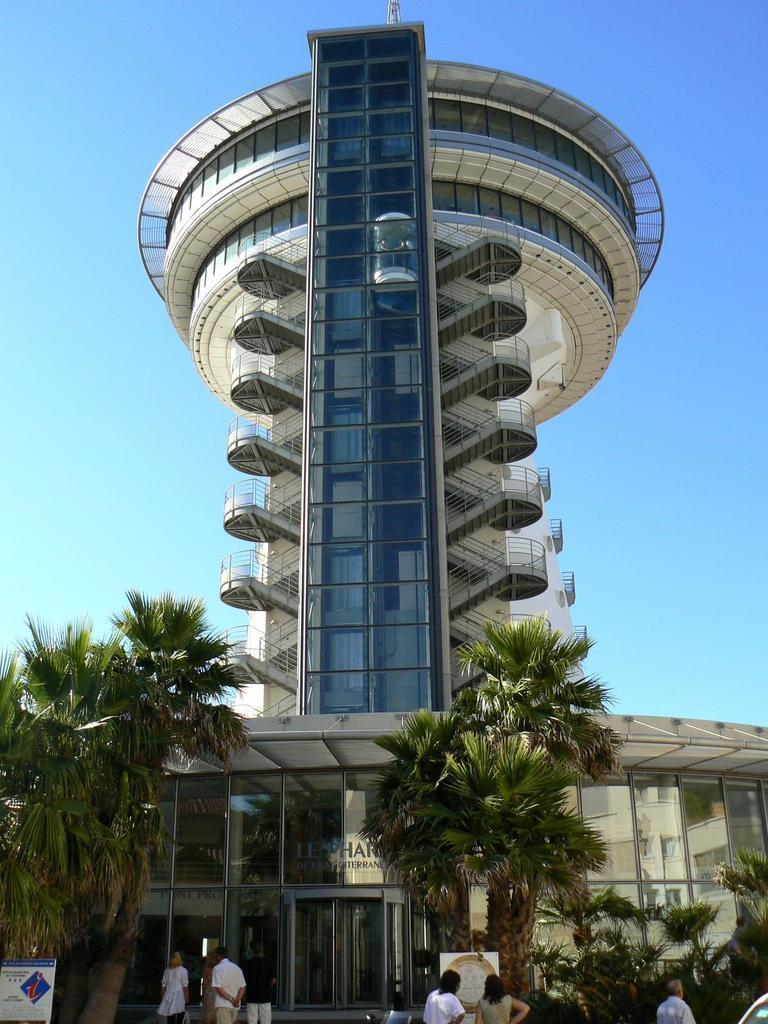Who or what can be seen in the image? There are people in the image. What type of structure is present in the image? There is a building in the image. What feature can be observed on the building? The building has windows. What type of natural elements are visible in the image? There are plants and trees in the image. What additional objects can be seen in the image? There are boards with text in the image. What can be seen in the background of the image? The sky is visible in the image. What type of baseball activity is taking place in the image? There is no baseball activity present in the image. Can you describe the tramp in the image? There is no tramp present in the image. 